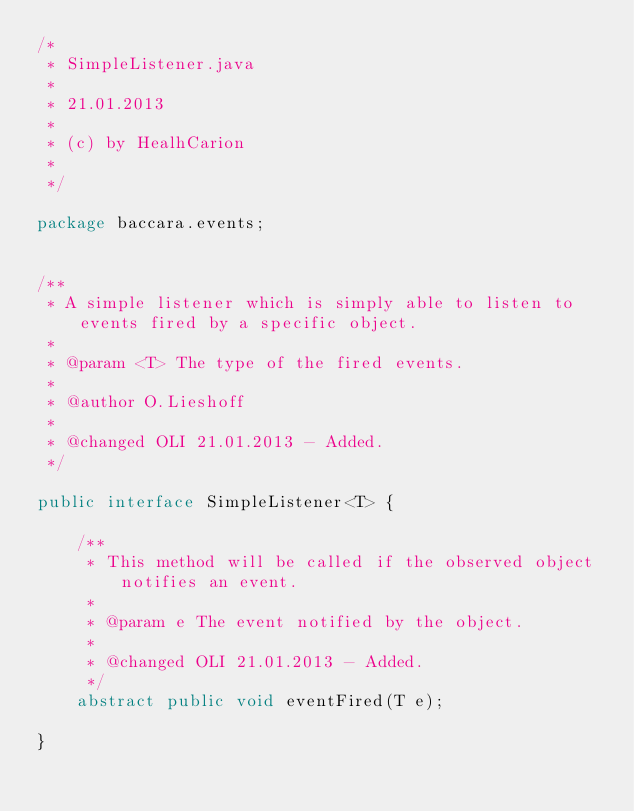<code> <loc_0><loc_0><loc_500><loc_500><_Java_>/*
 * SimpleListener.java
 *
 * 21.01.2013
 *
 * (c) by HealhCarion
 *
 */

package baccara.events;


/**
 * A simple listener which is simply able to listen to events fired by a specific object.
 *
 * @param <T> The type of the fired events.
 * 
 * @author O.Lieshoff
 *
 * @changed OLI 21.01.2013 - Added.
 */

public interface SimpleListener<T> {

    /**
     * This method will be called if the observed object notifies an event.
     *
     * @param e The event notified by the object.
     *
     * @changed OLI 21.01.2013 - Added.
     */
    abstract public void eventFired(T e);

}</code> 